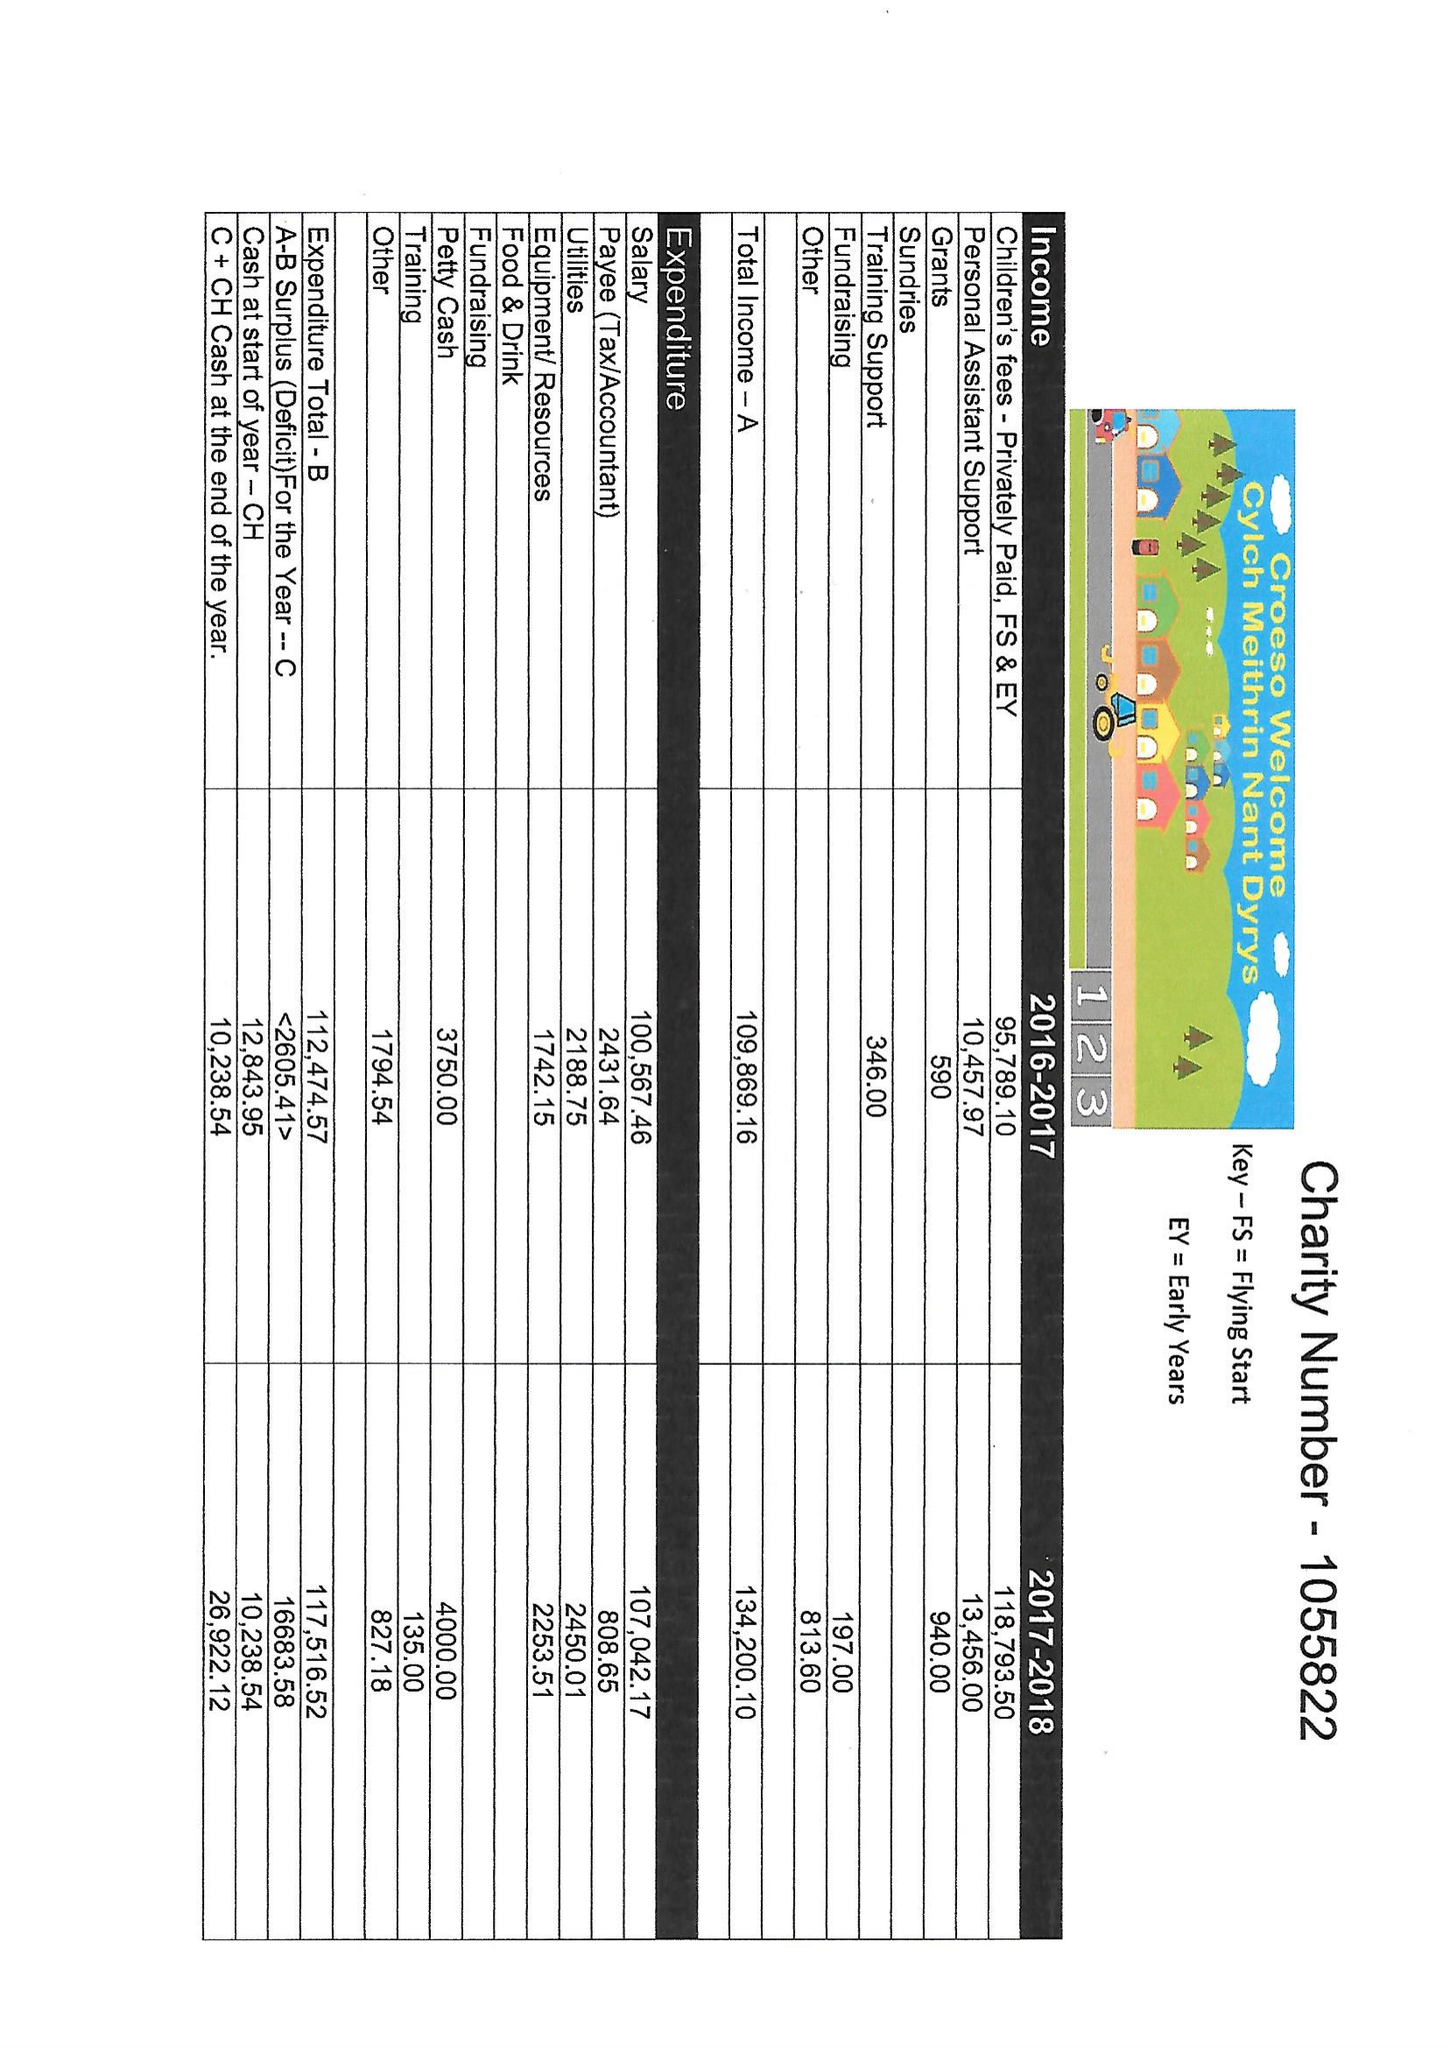What is the value for the address__postcode?
Answer the question using a single word or phrase. CF42 6ED 